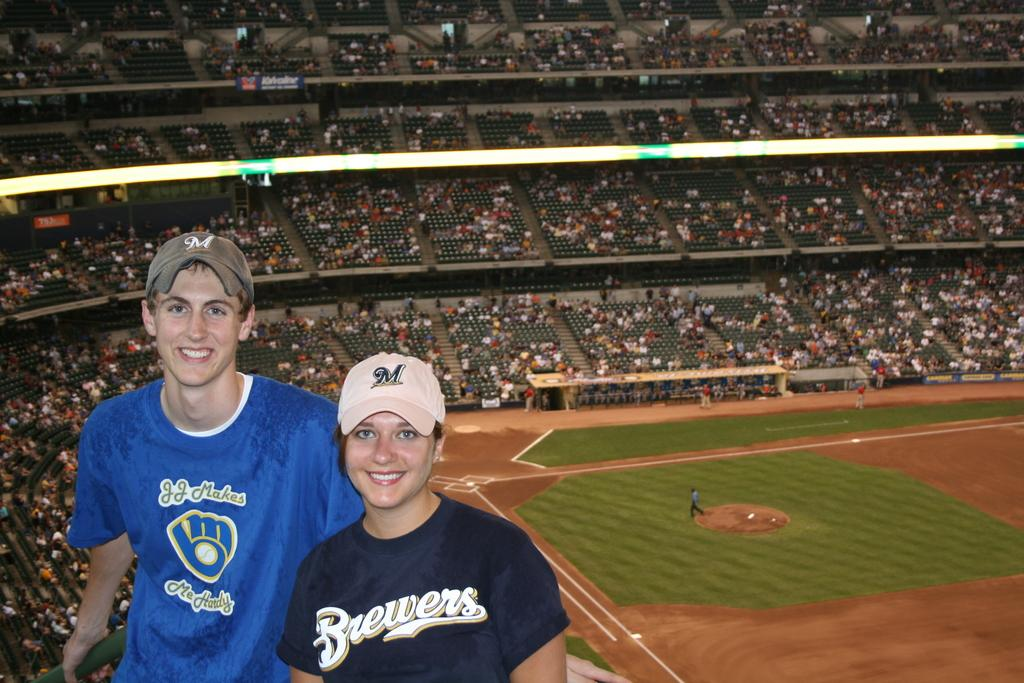<image>
Give a short and clear explanation of the subsequent image. A girl is standing in a stadium with a shirt on that has a Brewers logo on it. 